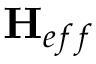Convert formula to latex. <formula><loc_0><loc_0><loc_500><loc_500>{ H } _ { e f f }</formula> 